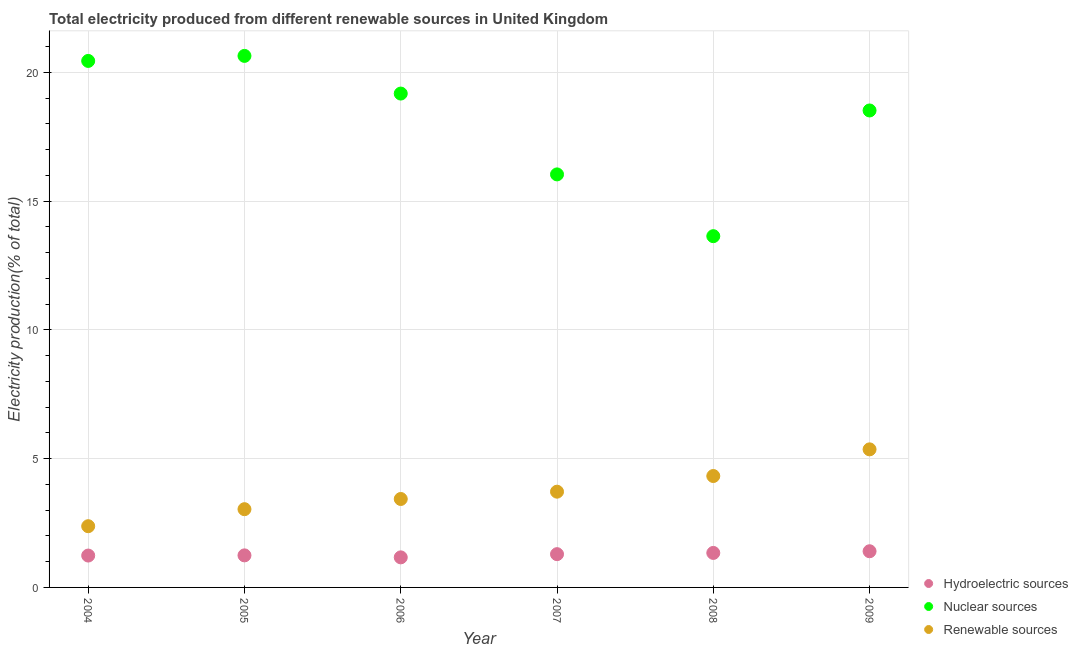Is the number of dotlines equal to the number of legend labels?
Make the answer very short. Yes. What is the percentage of electricity produced by hydroelectric sources in 2007?
Give a very brief answer. 1.29. Across all years, what is the maximum percentage of electricity produced by hydroelectric sources?
Ensure brevity in your answer.  1.4. Across all years, what is the minimum percentage of electricity produced by nuclear sources?
Offer a very short reply. 13.64. In which year was the percentage of electricity produced by hydroelectric sources maximum?
Provide a succinct answer. 2009. In which year was the percentage of electricity produced by hydroelectric sources minimum?
Provide a succinct answer. 2006. What is the total percentage of electricity produced by hydroelectric sources in the graph?
Make the answer very short. 7.69. What is the difference between the percentage of electricity produced by nuclear sources in 2004 and that in 2006?
Offer a very short reply. 1.27. What is the difference between the percentage of electricity produced by renewable sources in 2006 and the percentage of electricity produced by nuclear sources in 2004?
Your response must be concise. -17.01. What is the average percentage of electricity produced by hydroelectric sources per year?
Your response must be concise. 1.28. In the year 2009, what is the difference between the percentage of electricity produced by hydroelectric sources and percentage of electricity produced by nuclear sources?
Your answer should be compact. -17.12. What is the ratio of the percentage of electricity produced by renewable sources in 2004 to that in 2008?
Provide a succinct answer. 0.55. Is the percentage of electricity produced by renewable sources in 2005 less than that in 2008?
Offer a very short reply. Yes. What is the difference between the highest and the second highest percentage of electricity produced by nuclear sources?
Keep it short and to the point. 0.2. What is the difference between the highest and the lowest percentage of electricity produced by nuclear sources?
Offer a terse response. 7. In how many years, is the percentage of electricity produced by renewable sources greater than the average percentage of electricity produced by renewable sources taken over all years?
Ensure brevity in your answer.  3. Is the sum of the percentage of electricity produced by hydroelectric sources in 2004 and 2006 greater than the maximum percentage of electricity produced by nuclear sources across all years?
Ensure brevity in your answer.  No. Is the percentage of electricity produced by nuclear sources strictly less than the percentage of electricity produced by renewable sources over the years?
Offer a terse response. No. How many years are there in the graph?
Your answer should be very brief. 6. What is the difference between two consecutive major ticks on the Y-axis?
Keep it short and to the point. 5. Are the values on the major ticks of Y-axis written in scientific E-notation?
Your answer should be compact. No. Does the graph contain grids?
Offer a terse response. Yes. How are the legend labels stacked?
Offer a terse response. Vertical. What is the title of the graph?
Give a very brief answer. Total electricity produced from different renewable sources in United Kingdom. Does "Taxes on goods and services" appear as one of the legend labels in the graph?
Provide a short and direct response. No. What is the label or title of the X-axis?
Offer a very short reply. Year. What is the Electricity production(% of total) of Hydroelectric sources in 2004?
Your answer should be very brief. 1.24. What is the Electricity production(% of total) of Nuclear sources in 2004?
Provide a succinct answer. 20.45. What is the Electricity production(% of total) of Renewable sources in 2004?
Make the answer very short. 2.38. What is the Electricity production(% of total) of Hydroelectric sources in 2005?
Ensure brevity in your answer.  1.24. What is the Electricity production(% of total) in Nuclear sources in 2005?
Your answer should be very brief. 20.64. What is the Electricity production(% of total) of Renewable sources in 2005?
Give a very brief answer. 3.04. What is the Electricity production(% of total) in Hydroelectric sources in 2006?
Make the answer very short. 1.17. What is the Electricity production(% of total) in Nuclear sources in 2006?
Offer a very short reply. 19.18. What is the Electricity production(% of total) of Renewable sources in 2006?
Your response must be concise. 3.43. What is the Electricity production(% of total) of Hydroelectric sources in 2007?
Provide a short and direct response. 1.29. What is the Electricity production(% of total) of Nuclear sources in 2007?
Offer a terse response. 16.04. What is the Electricity production(% of total) of Renewable sources in 2007?
Your answer should be compact. 3.72. What is the Electricity production(% of total) in Hydroelectric sources in 2008?
Provide a succinct answer. 1.34. What is the Electricity production(% of total) of Nuclear sources in 2008?
Give a very brief answer. 13.64. What is the Electricity production(% of total) in Renewable sources in 2008?
Keep it short and to the point. 4.33. What is the Electricity production(% of total) in Hydroelectric sources in 2009?
Your answer should be very brief. 1.4. What is the Electricity production(% of total) of Nuclear sources in 2009?
Ensure brevity in your answer.  18.52. What is the Electricity production(% of total) in Renewable sources in 2009?
Offer a very short reply. 5.36. Across all years, what is the maximum Electricity production(% of total) of Hydroelectric sources?
Your answer should be very brief. 1.4. Across all years, what is the maximum Electricity production(% of total) of Nuclear sources?
Ensure brevity in your answer.  20.64. Across all years, what is the maximum Electricity production(% of total) in Renewable sources?
Give a very brief answer. 5.36. Across all years, what is the minimum Electricity production(% of total) of Hydroelectric sources?
Your answer should be compact. 1.17. Across all years, what is the minimum Electricity production(% of total) of Nuclear sources?
Your answer should be very brief. 13.64. Across all years, what is the minimum Electricity production(% of total) of Renewable sources?
Provide a succinct answer. 2.38. What is the total Electricity production(% of total) of Hydroelectric sources in the graph?
Ensure brevity in your answer.  7.69. What is the total Electricity production(% of total) in Nuclear sources in the graph?
Your response must be concise. 108.46. What is the total Electricity production(% of total) of Renewable sources in the graph?
Offer a very short reply. 22.26. What is the difference between the Electricity production(% of total) in Hydroelectric sources in 2004 and that in 2005?
Give a very brief answer. -0.01. What is the difference between the Electricity production(% of total) in Nuclear sources in 2004 and that in 2005?
Offer a terse response. -0.2. What is the difference between the Electricity production(% of total) of Renewable sources in 2004 and that in 2005?
Offer a very short reply. -0.66. What is the difference between the Electricity production(% of total) in Hydroelectric sources in 2004 and that in 2006?
Your answer should be very brief. 0.07. What is the difference between the Electricity production(% of total) in Nuclear sources in 2004 and that in 2006?
Make the answer very short. 1.27. What is the difference between the Electricity production(% of total) in Renewable sources in 2004 and that in 2006?
Offer a terse response. -1.06. What is the difference between the Electricity production(% of total) in Hydroelectric sources in 2004 and that in 2007?
Make the answer very short. -0.05. What is the difference between the Electricity production(% of total) in Nuclear sources in 2004 and that in 2007?
Make the answer very short. 4.41. What is the difference between the Electricity production(% of total) of Renewable sources in 2004 and that in 2007?
Keep it short and to the point. -1.34. What is the difference between the Electricity production(% of total) of Hydroelectric sources in 2004 and that in 2008?
Keep it short and to the point. -0.1. What is the difference between the Electricity production(% of total) in Nuclear sources in 2004 and that in 2008?
Make the answer very short. 6.8. What is the difference between the Electricity production(% of total) in Renewable sources in 2004 and that in 2008?
Ensure brevity in your answer.  -1.95. What is the difference between the Electricity production(% of total) of Hydroelectric sources in 2004 and that in 2009?
Ensure brevity in your answer.  -0.17. What is the difference between the Electricity production(% of total) in Nuclear sources in 2004 and that in 2009?
Make the answer very short. 1.92. What is the difference between the Electricity production(% of total) of Renewable sources in 2004 and that in 2009?
Your answer should be very brief. -2.98. What is the difference between the Electricity production(% of total) in Hydroelectric sources in 2005 and that in 2006?
Your answer should be compact. 0.08. What is the difference between the Electricity production(% of total) of Nuclear sources in 2005 and that in 2006?
Your answer should be compact. 1.46. What is the difference between the Electricity production(% of total) in Renewable sources in 2005 and that in 2006?
Your response must be concise. -0.4. What is the difference between the Electricity production(% of total) in Hydroelectric sources in 2005 and that in 2007?
Offer a terse response. -0.05. What is the difference between the Electricity production(% of total) of Nuclear sources in 2005 and that in 2007?
Offer a terse response. 4.6. What is the difference between the Electricity production(% of total) in Renewable sources in 2005 and that in 2007?
Give a very brief answer. -0.68. What is the difference between the Electricity production(% of total) in Hydroelectric sources in 2005 and that in 2008?
Provide a succinct answer. -0.1. What is the difference between the Electricity production(% of total) of Nuclear sources in 2005 and that in 2008?
Offer a very short reply. 7. What is the difference between the Electricity production(% of total) in Renewable sources in 2005 and that in 2008?
Provide a succinct answer. -1.29. What is the difference between the Electricity production(% of total) in Hydroelectric sources in 2005 and that in 2009?
Your response must be concise. -0.16. What is the difference between the Electricity production(% of total) in Nuclear sources in 2005 and that in 2009?
Provide a short and direct response. 2.12. What is the difference between the Electricity production(% of total) of Renewable sources in 2005 and that in 2009?
Ensure brevity in your answer.  -2.32. What is the difference between the Electricity production(% of total) of Hydroelectric sources in 2006 and that in 2007?
Give a very brief answer. -0.12. What is the difference between the Electricity production(% of total) of Nuclear sources in 2006 and that in 2007?
Your answer should be compact. 3.14. What is the difference between the Electricity production(% of total) of Renewable sources in 2006 and that in 2007?
Give a very brief answer. -0.28. What is the difference between the Electricity production(% of total) in Hydroelectric sources in 2006 and that in 2008?
Your answer should be very brief. -0.17. What is the difference between the Electricity production(% of total) in Nuclear sources in 2006 and that in 2008?
Your answer should be compact. 5.54. What is the difference between the Electricity production(% of total) of Renewable sources in 2006 and that in 2008?
Your answer should be compact. -0.89. What is the difference between the Electricity production(% of total) of Hydroelectric sources in 2006 and that in 2009?
Provide a short and direct response. -0.24. What is the difference between the Electricity production(% of total) in Nuclear sources in 2006 and that in 2009?
Your response must be concise. 0.66. What is the difference between the Electricity production(% of total) of Renewable sources in 2006 and that in 2009?
Your answer should be compact. -1.93. What is the difference between the Electricity production(% of total) of Hydroelectric sources in 2007 and that in 2008?
Your answer should be compact. -0.05. What is the difference between the Electricity production(% of total) of Nuclear sources in 2007 and that in 2008?
Your answer should be compact. 2.4. What is the difference between the Electricity production(% of total) in Renewable sources in 2007 and that in 2008?
Your answer should be compact. -0.61. What is the difference between the Electricity production(% of total) of Hydroelectric sources in 2007 and that in 2009?
Provide a short and direct response. -0.11. What is the difference between the Electricity production(% of total) of Nuclear sources in 2007 and that in 2009?
Your answer should be very brief. -2.48. What is the difference between the Electricity production(% of total) of Renewable sources in 2007 and that in 2009?
Make the answer very short. -1.64. What is the difference between the Electricity production(% of total) in Hydroelectric sources in 2008 and that in 2009?
Ensure brevity in your answer.  -0.07. What is the difference between the Electricity production(% of total) of Nuclear sources in 2008 and that in 2009?
Provide a short and direct response. -4.88. What is the difference between the Electricity production(% of total) in Renewable sources in 2008 and that in 2009?
Keep it short and to the point. -1.04. What is the difference between the Electricity production(% of total) of Hydroelectric sources in 2004 and the Electricity production(% of total) of Nuclear sources in 2005?
Offer a very short reply. -19.4. What is the difference between the Electricity production(% of total) of Hydroelectric sources in 2004 and the Electricity production(% of total) of Renewable sources in 2005?
Your answer should be very brief. -1.8. What is the difference between the Electricity production(% of total) of Nuclear sources in 2004 and the Electricity production(% of total) of Renewable sources in 2005?
Provide a succinct answer. 17.41. What is the difference between the Electricity production(% of total) of Hydroelectric sources in 2004 and the Electricity production(% of total) of Nuclear sources in 2006?
Make the answer very short. -17.94. What is the difference between the Electricity production(% of total) in Hydroelectric sources in 2004 and the Electricity production(% of total) in Renewable sources in 2006?
Offer a terse response. -2.2. What is the difference between the Electricity production(% of total) in Nuclear sources in 2004 and the Electricity production(% of total) in Renewable sources in 2006?
Your answer should be compact. 17.01. What is the difference between the Electricity production(% of total) in Hydroelectric sources in 2004 and the Electricity production(% of total) in Nuclear sources in 2007?
Provide a short and direct response. -14.8. What is the difference between the Electricity production(% of total) in Hydroelectric sources in 2004 and the Electricity production(% of total) in Renewable sources in 2007?
Offer a terse response. -2.48. What is the difference between the Electricity production(% of total) of Nuclear sources in 2004 and the Electricity production(% of total) of Renewable sources in 2007?
Offer a terse response. 16.73. What is the difference between the Electricity production(% of total) of Hydroelectric sources in 2004 and the Electricity production(% of total) of Nuclear sources in 2008?
Your answer should be very brief. -12.4. What is the difference between the Electricity production(% of total) of Hydroelectric sources in 2004 and the Electricity production(% of total) of Renewable sources in 2008?
Make the answer very short. -3.09. What is the difference between the Electricity production(% of total) of Nuclear sources in 2004 and the Electricity production(% of total) of Renewable sources in 2008?
Your answer should be compact. 16.12. What is the difference between the Electricity production(% of total) in Hydroelectric sources in 2004 and the Electricity production(% of total) in Nuclear sources in 2009?
Keep it short and to the point. -17.28. What is the difference between the Electricity production(% of total) of Hydroelectric sources in 2004 and the Electricity production(% of total) of Renewable sources in 2009?
Offer a terse response. -4.12. What is the difference between the Electricity production(% of total) of Nuclear sources in 2004 and the Electricity production(% of total) of Renewable sources in 2009?
Keep it short and to the point. 15.08. What is the difference between the Electricity production(% of total) in Hydroelectric sources in 2005 and the Electricity production(% of total) in Nuclear sources in 2006?
Keep it short and to the point. -17.93. What is the difference between the Electricity production(% of total) in Hydroelectric sources in 2005 and the Electricity production(% of total) in Renewable sources in 2006?
Give a very brief answer. -2.19. What is the difference between the Electricity production(% of total) of Nuclear sources in 2005 and the Electricity production(% of total) of Renewable sources in 2006?
Ensure brevity in your answer.  17.21. What is the difference between the Electricity production(% of total) in Hydroelectric sources in 2005 and the Electricity production(% of total) in Nuclear sources in 2007?
Keep it short and to the point. -14.79. What is the difference between the Electricity production(% of total) of Hydroelectric sources in 2005 and the Electricity production(% of total) of Renewable sources in 2007?
Make the answer very short. -2.47. What is the difference between the Electricity production(% of total) in Nuclear sources in 2005 and the Electricity production(% of total) in Renewable sources in 2007?
Make the answer very short. 16.92. What is the difference between the Electricity production(% of total) in Hydroelectric sources in 2005 and the Electricity production(% of total) in Nuclear sources in 2008?
Offer a very short reply. -12.4. What is the difference between the Electricity production(% of total) of Hydroelectric sources in 2005 and the Electricity production(% of total) of Renewable sources in 2008?
Your answer should be compact. -3.08. What is the difference between the Electricity production(% of total) of Nuclear sources in 2005 and the Electricity production(% of total) of Renewable sources in 2008?
Your answer should be compact. 16.31. What is the difference between the Electricity production(% of total) in Hydroelectric sources in 2005 and the Electricity production(% of total) in Nuclear sources in 2009?
Give a very brief answer. -17.28. What is the difference between the Electricity production(% of total) of Hydroelectric sources in 2005 and the Electricity production(% of total) of Renewable sources in 2009?
Offer a very short reply. -4.12. What is the difference between the Electricity production(% of total) in Nuclear sources in 2005 and the Electricity production(% of total) in Renewable sources in 2009?
Offer a very short reply. 15.28. What is the difference between the Electricity production(% of total) in Hydroelectric sources in 2006 and the Electricity production(% of total) in Nuclear sources in 2007?
Provide a succinct answer. -14.87. What is the difference between the Electricity production(% of total) in Hydroelectric sources in 2006 and the Electricity production(% of total) in Renewable sources in 2007?
Ensure brevity in your answer.  -2.55. What is the difference between the Electricity production(% of total) of Nuclear sources in 2006 and the Electricity production(% of total) of Renewable sources in 2007?
Provide a short and direct response. 15.46. What is the difference between the Electricity production(% of total) of Hydroelectric sources in 2006 and the Electricity production(% of total) of Nuclear sources in 2008?
Keep it short and to the point. -12.47. What is the difference between the Electricity production(% of total) in Hydroelectric sources in 2006 and the Electricity production(% of total) in Renewable sources in 2008?
Offer a very short reply. -3.16. What is the difference between the Electricity production(% of total) of Nuclear sources in 2006 and the Electricity production(% of total) of Renewable sources in 2008?
Keep it short and to the point. 14.85. What is the difference between the Electricity production(% of total) in Hydroelectric sources in 2006 and the Electricity production(% of total) in Nuclear sources in 2009?
Offer a very short reply. -17.35. What is the difference between the Electricity production(% of total) in Hydroelectric sources in 2006 and the Electricity production(% of total) in Renewable sources in 2009?
Offer a terse response. -4.19. What is the difference between the Electricity production(% of total) of Nuclear sources in 2006 and the Electricity production(% of total) of Renewable sources in 2009?
Make the answer very short. 13.82. What is the difference between the Electricity production(% of total) of Hydroelectric sources in 2007 and the Electricity production(% of total) of Nuclear sources in 2008?
Provide a succinct answer. -12.35. What is the difference between the Electricity production(% of total) of Hydroelectric sources in 2007 and the Electricity production(% of total) of Renewable sources in 2008?
Provide a succinct answer. -3.03. What is the difference between the Electricity production(% of total) of Nuclear sources in 2007 and the Electricity production(% of total) of Renewable sources in 2008?
Give a very brief answer. 11.71. What is the difference between the Electricity production(% of total) in Hydroelectric sources in 2007 and the Electricity production(% of total) in Nuclear sources in 2009?
Ensure brevity in your answer.  -17.23. What is the difference between the Electricity production(% of total) in Hydroelectric sources in 2007 and the Electricity production(% of total) in Renewable sources in 2009?
Make the answer very short. -4.07. What is the difference between the Electricity production(% of total) of Nuclear sources in 2007 and the Electricity production(% of total) of Renewable sources in 2009?
Your response must be concise. 10.68. What is the difference between the Electricity production(% of total) of Hydroelectric sources in 2008 and the Electricity production(% of total) of Nuclear sources in 2009?
Offer a very short reply. -17.18. What is the difference between the Electricity production(% of total) of Hydroelectric sources in 2008 and the Electricity production(% of total) of Renewable sources in 2009?
Your answer should be compact. -4.02. What is the difference between the Electricity production(% of total) of Nuclear sources in 2008 and the Electricity production(% of total) of Renewable sources in 2009?
Give a very brief answer. 8.28. What is the average Electricity production(% of total) in Hydroelectric sources per year?
Offer a very short reply. 1.28. What is the average Electricity production(% of total) in Nuclear sources per year?
Keep it short and to the point. 18.08. What is the average Electricity production(% of total) of Renewable sources per year?
Offer a very short reply. 3.71. In the year 2004, what is the difference between the Electricity production(% of total) of Hydroelectric sources and Electricity production(% of total) of Nuclear sources?
Offer a terse response. -19.21. In the year 2004, what is the difference between the Electricity production(% of total) of Hydroelectric sources and Electricity production(% of total) of Renewable sources?
Your answer should be very brief. -1.14. In the year 2004, what is the difference between the Electricity production(% of total) in Nuclear sources and Electricity production(% of total) in Renewable sources?
Your answer should be very brief. 18.07. In the year 2005, what is the difference between the Electricity production(% of total) of Hydroelectric sources and Electricity production(% of total) of Nuclear sources?
Offer a terse response. -19.4. In the year 2005, what is the difference between the Electricity production(% of total) of Hydroelectric sources and Electricity production(% of total) of Renewable sources?
Give a very brief answer. -1.79. In the year 2005, what is the difference between the Electricity production(% of total) in Nuclear sources and Electricity production(% of total) in Renewable sources?
Give a very brief answer. 17.6. In the year 2006, what is the difference between the Electricity production(% of total) in Hydroelectric sources and Electricity production(% of total) in Nuclear sources?
Give a very brief answer. -18.01. In the year 2006, what is the difference between the Electricity production(% of total) in Hydroelectric sources and Electricity production(% of total) in Renewable sources?
Provide a succinct answer. -2.27. In the year 2006, what is the difference between the Electricity production(% of total) of Nuclear sources and Electricity production(% of total) of Renewable sources?
Offer a terse response. 15.74. In the year 2007, what is the difference between the Electricity production(% of total) in Hydroelectric sources and Electricity production(% of total) in Nuclear sources?
Your answer should be very brief. -14.75. In the year 2007, what is the difference between the Electricity production(% of total) in Hydroelectric sources and Electricity production(% of total) in Renewable sources?
Provide a short and direct response. -2.43. In the year 2007, what is the difference between the Electricity production(% of total) of Nuclear sources and Electricity production(% of total) of Renewable sources?
Your response must be concise. 12.32. In the year 2008, what is the difference between the Electricity production(% of total) of Hydroelectric sources and Electricity production(% of total) of Nuclear sources?
Ensure brevity in your answer.  -12.3. In the year 2008, what is the difference between the Electricity production(% of total) of Hydroelectric sources and Electricity production(% of total) of Renewable sources?
Ensure brevity in your answer.  -2.99. In the year 2008, what is the difference between the Electricity production(% of total) of Nuclear sources and Electricity production(% of total) of Renewable sources?
Keep it short and to the point. 9.31. In the year 2009, what is the difference between the Electricity production(% of total) of Hydroelectric sources and Electricity production(% of total) of Nuclear sources?
Ensure brevity in your answer.  -17.12. In the year 2009, what is the difference between the Electricity production(% of total) of Hydroelectric sources and Electricity production(% of total) of Renewable sources?
Provide a short and direct response. -3.96. In the year 2009, what is the difference between the Electricity production(% of total) in Nuclear sources and Electricity production(% of total) in Renewable sources?
Provide a succinct answer. 13.16. What is the ratio of the Electricity production(% of total) in Hydroelectric sources in 2004 to that in 2005?
Make the answer very short. 0.99. What is the ratio of the Electricity production(% of total) in Nuclear sources in 2004 to that in 2005?
Keep it short and to the point. 0.99. What is the ratio of the Electricity production(% of total) of Renewable sources in 2004 to that in 2005?
Give a very brief answer. 0.78. What is the ratio of the Electricity production(% of total) of Hydroelectric sources in 2004 to that in 2006?
Provide a succinct answer. 1.06. What is the ratio of the Electricity production(% of total) of Nuclear sources in 2004 to that in 2006?
Keep it short and to the point. 1.07. What is the ratio of the Electricity production(% of total) in Renewable sources in 2004 to that in 2006?
Make the answer very short. 0.69. What is the ratio of the Electricity production(% of total) in Hydroelectric sources in 2004 to that in 2007?
Offer a very short reply. 0.96. What is the ratio of the Electricity production(% of total) in Nuclear sources in 2004 to that in 2007?
Offer a very short reply. 1.27. What is the ratio of the Electricity production(% of total) of Renewable sources in 2004 to that in 2007?
Offer a very short reply. 0.64. What is the ratio of the Electricity production(% of total) in Hydroelectric sources in 2004 to that in 2008?
Offer a terse response. 0.92. What is the ratio of the Electricity production(% of total) in Nuclear sources in 2004 to that in 2008?
Give a very brief answer. 1.5. What is the ratio of the Electricity production(% of total) in Renewable sources in 2004 to that in 2008?
Your response must be concise. 0.55. What is the ratio of the Electricity production(% of total) in Hydroelectric sources in 2004 to that in 2009?
Provide a short and direct response. 0.88. What is the ratio of the Electricity production(% of total) of Nuclear sources in 2004 to that in 2009?
Your answer should be very brief. 1.1. What is the ratio of the Electricity production(% of total) in Renewable sources in 2004 to that in 2009?
Give a very brief answer. 0.44. What is the ratio of the Electricity production(% of total) in Hydroelectric sources in 2005 to that in 2006?
Offer a very short reply. 1.07. What is the ratio of the Electricity production(% of total) in Nuclear sources in 2005 to that in 2006?
Offer a terse response. 1.08. What is the ratio of the Electricity production(% of total) in Renewable sources in 2005 to that in 2006?
Provide a succinct answer. 0.88. What is the ratio of the Electricity production(% of total) in Hydroelectric sources in 2005 to that in 2007?
Your answer should be very brief. 0.96. What is the ratio of the Electricity production(% of total) in Nuclear sources in 2005 to that in 2007?
Your answer should be compact. 1.29. What is the ratio of the Electricity production(% of total) in Renewable sources in 2005 to that in 2007?
Offer a terse response. 0.82. What is the ratio of the Electricity production(% of total) of Hydroelectric sources in 2005 to that in 2008?
Offer a terse response. 0.93. What is the ratio of the Electricity production(% of total) in Nuclear sources in 2005 to that in 2008?
Provide a succinct answer. 1.51. What is the ratio of the Electricity production(% of total) in Renewable sources in 2005 to that in 2008?
Your response must be concise. 0.7. What is the ratio of the Electricity production(% of total) of Hydroelectric sources in 2005 to that in 2009?
Your answer should be very brief. 0.89. What is the ratio of the Electricity production(% of total) in Nuclear sources in 2005 to that in 2009?
Your answer should be compact. 1.11. What is the ratio of the Electricity production(% of total) of Renewable sources in 2005 to that in 2009?
Your response must be concise. 0.57. What is the ratio of the Electricity production(% of total) of Hydroelectric sources in 2006 to that in 2007?
Make the answer very short. 0.9. What is the ratio of the Electricity production(% of total) of Nuclear sources in 2006 to that in 2007?
Make the answer very short. 1.2. What is the ratio of the Electricity production(% of total) of Renewable sources in 2006 to that in 2007?
Offer a very short reply. 0.92. What is the ratio of the Electricity production(% of total) in Hydroelectric sources in 2006 to that in 2008?
Your answer should be very brief. 0.87. What is the ratio of the Electricity production(% of total) of Nuclear sources in 2006 to that in 2008?
Give a very brief answer. 1.41. What is the ratio of the Electricity production(% of total) in Renewable sources in 2006 to that in 2008?
Your response must be concise. 0.79. What is the ratio of the Electricity production(% of total) in Hydroelectric sources in 2006 to that in 2009?
Offer a terse response. 0.83. What is the ratio of the Electricity production(% of total) of Nuclear sources in 2006 to that in 2009?
Your answer should be compact. 1.04. What is the ratio of the Electricity production(% of total) of Renewable sources in 2006 to that in 2009?
Keep it short and to the point. 0.64. What is the ratio of the Electricity production(% of total) in Hydroelectric sources in 2007 to that in 2008?
Your answer should be very brief. 0.96. What is the ratio of the Electricity production(% of total) in Nuclear sources in 2007 to that in 2008?
Your answer should be compact. 1.18. What is the ratio of the Electricity production(% of total) of Renewable sources in 2007 to that in 2008?
Offer a terse response. 0.86. What is the ratio of the Electricity production(% of total) of Hydroelectric sources in 2007 to that in 2009?
Your response must be concise. 0.92. What is the ratio of the Electricity production(% of total) in Nuclear sources in 2007 to that in 2009?
Offer a very short reply. 0.87. What is the ratio of the Electricity production(% of total) of Renewable sources in 2007 to that in 2009?
Provide a succinct answer. 0.69. What is the ratio of the Electricity production(% of total) of Hydroelectric sources in 2008 to that in 2009?
Your answer should be very brief. 0.95. What is the ratio of the Electricity production(% of total) of Nuclear sources in 2008 to that in 2009?
Provide a short and direct response. 0.74. What is the ratio of the Electricity production(% of total) of Renewable sources in 2008 to that in 2009?
Offer a very short reply. 0.81. What is the difference between the highest and the second highest Electricity production(% of total) in Hydroelectric sources?
Your answer should be very brief. 0.07. What is the difference between the highest and the second highest Electricity production(% of total) of Nuclear sources?
Make the answer very short. 0.2. What is the difference between the highest and the second highest Electricity production(% of total) in Renewable sources?
Your answer should be very brief. 1.04. What is the difference between the highest and the lowest Electricity production(% of total) in Hydroelectric sources?
Provide a short and direct response. 0.24. What is the difference between the highest and the lowest Electricity production(% of total) in Nuclear sources?
Offer a terse response. 7. What is the difference between the highest and the lowest Electricity production(% of total) of Renewable sources?
Your answer should be very brief. 2.98. 